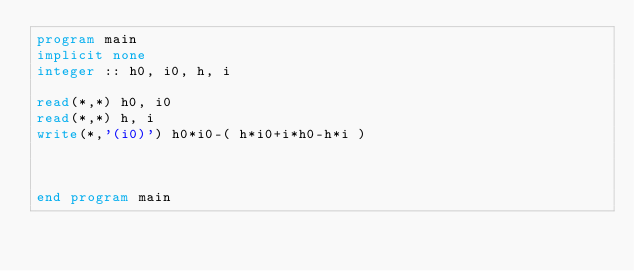Convert code to text. <code><loc_0><loc_0><loc_500><loc_500><_FORTRAN_>program main
implicit none
integer :: h0, i0, h, i

read(*,*) h0, i0
read(*,*) h, i
write(*,'(i0)') h0*i0-( h*i0+i*h0-h*i )



end program main
</code> 